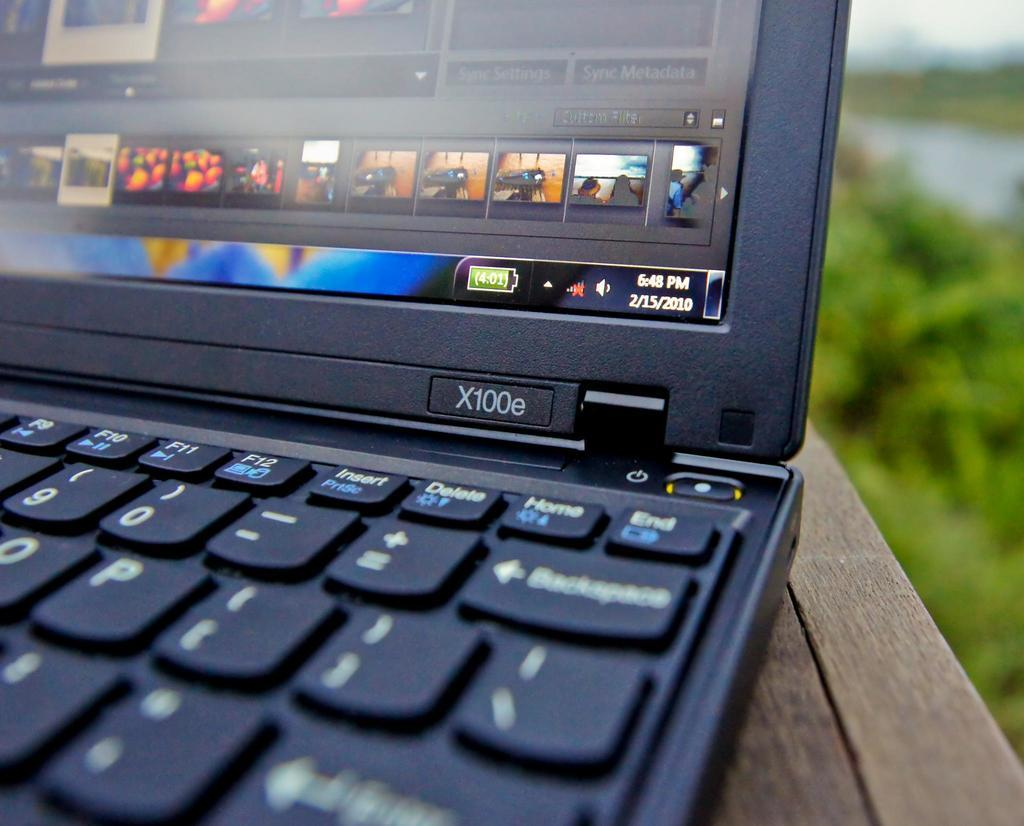Provide a one-sentence caption for the provided image. An X100e laptop is open and shows that the date is 2/15/2010. 